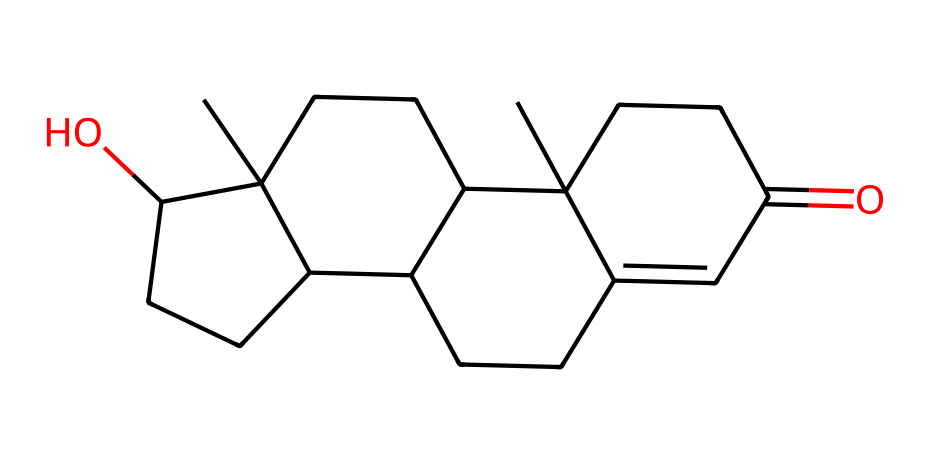What is the molecular formula of this hormone? To determine the molecular formula, we can analyze the SMILES representation. By counting the carbon (C), hydrogen (H), and oxygen (O) atoms from the structure denoted in the SMILES notation, we find there are 19 carbon atoms, 28 hydrogen atoms, and 2 oxygen atoms, yielding the formula C19H28O2.
Answer: C19H28O2 How many rings are present in the chemical structure? The chemical structure can be examined for cycloalkane or ring structures. In the SMILES string, we can see the use of ring closure indicators (the numbers) that suggest multiple interconnected cycles. The molecule contains four rings in total based on the numbers used in the SMILES.
Answer: 4 What type of compound is testosterone classified as? Testosterone, based on its chemical structure and function, is a type of steroid hormone, which is characterized by its tetracyclic structure. The presence of four interconnected rings signifies its classification in this category.
Answer: steroid Which part of the molecule contains the hydroxyl group? In the SMILES representation, the 'O' in the context of hydroxyl (–OH) typically indicates its presence. The specific placement of the 'O' between two carbon structures suggests that it's part of a hydroxyl group. In this case, the position linked to the structure indicates that there is a hydroxyl group on one of the rings.
Answer: hydroxyl group What does the carbonyl group contribute to the structure? The carbonyl group (C=O) contributes to structural features and reactivity; it appears in the molecule and influences the functionality of hormones, as seen in the ketone structure resulting from this functional group. The presence of this carbonyl in the structure indicates that it may affect how the hormone interacts with receptors.
Answer: reactivity How does this hormone typically influence physical performance? Testosterone is known to influence physical labor and performance by promoting muscle development and strength, thus enhancing the physical capabilities of individuals. This hormone plays a significant role in the adaptive mechanisms for energy production during physical exertion.
Answer: muscle development 